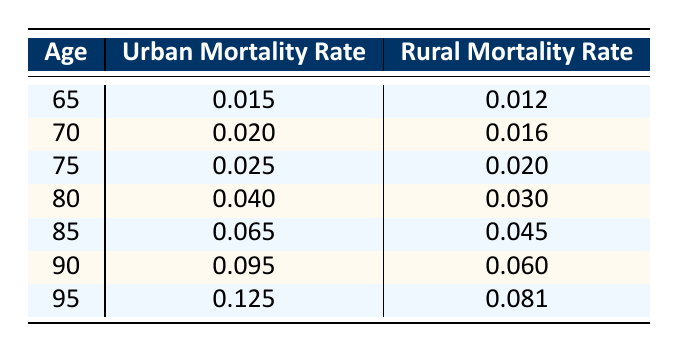What is the Urban Mortality Rate for those aged 80? According to the table, the Urban Mortality Rate for individuals aged 80 is listed directly. It shows 0.040 as the mortality rate.
Answer: 0.040 What is the Rural Mortality Rate for those aged 70 compared to those aged 75? From the table, the Rural Mortality Rates are 0.016 for age 70 and 0.020 for age 75. Therefore, the 75-year-olds have a higher mortality rate.
Answer: Yes, it is higher What is the difference in Urban Mortality Rates between ages 85 and 95? To find the difference, we subtract the Urban Mortality Rate for age 95 (0.125) from that for age 85 (0.065): 0.125 - 0.065 = 0.060.
Answer: 0.060 Is the Rural Mortality Rate for 90-year-olds higher than for 80-year-olds? The Rural Mortality Rate for 90-year-olds is 0.060, while for 80-year-olds, it is 0.030. Thus, it is indeed higher for the 90-year-olds.
Answer: Yes What is the average Urban Mortality Rate for those aged 65, 70, and 75? To find the average, we first sum the Urban Mortality Rates for these ages: 0.015 + 0.020 + 0.025 = 0.060. Then we divide by the number of age groups (3): 0.060/3 = 0.020.
Answer: 0.020 How does the Urban Mortality Rate increase from age 65 to age 95? The Urban Mortality Rate for age 65 is 0.015, and for age 95, it is 0.125. To calculate the increase, we find the difference: 0.125 - 0.015 = 0.110.
Answer: 0.110 Is the Rural Mortality Rate consistently lower than the Urban Mortality Rate across all age groups? Reviewing the table, the Urban Mortality Rates are greater than the Rural Mortality Rates at each age group provided, confirming the statement is true.
Answer: Yes What is the total Urban Mortality Rate for all age groups listed in the table? We add together the Urban Mortality Rates: 0.015 + 0.020 + 0.025 + 0.040 + 0.065 + 0.095 + 0.125 = 0.395.
Answer: 0.395 How much more significant is the Urban Mortality Rate at age 90 compared to age 65? We find the difference between the Urban Mortality Rate at age 90 (0.095) and age 65 (0.015): 0.095 - 0.015 = 0.080.
Answer: 0.080 